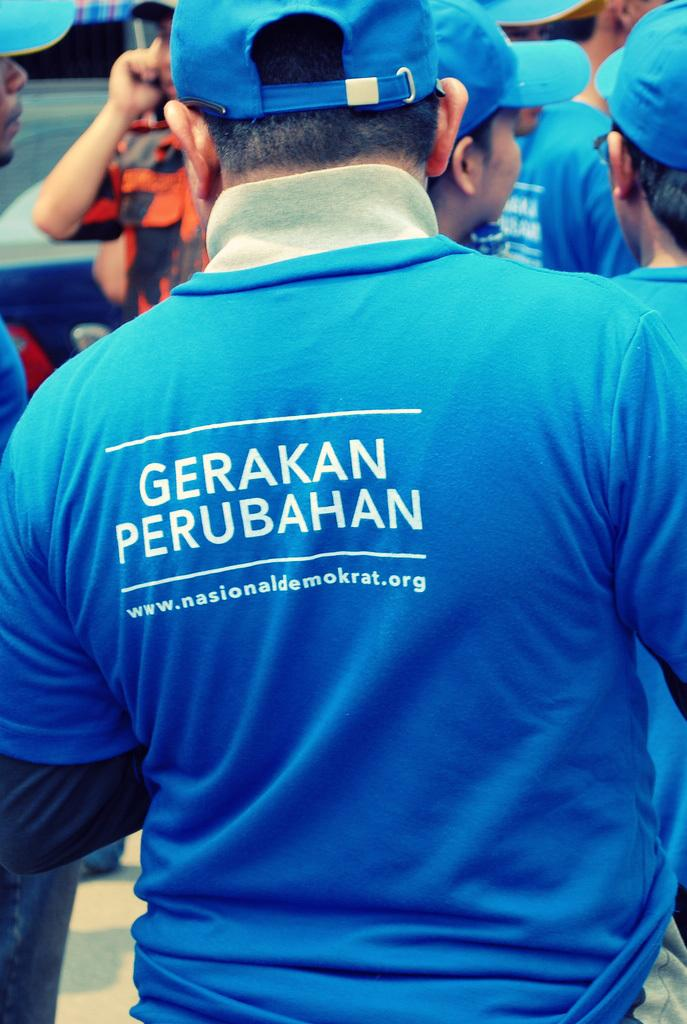What is the main subject of the image? The main subject of the image is a group of people. What are the people wearing on their heads? The people are wearing blue color caps. What else are the people wearing that is the same color as their caps? The people are also wearing blue color t-shirts. What type of pin can be seen on the people's t-shirts in the image? There is no pin visible on the people's t-shirts in the image. What kind of chain is connecting the people in the image? There is no chain connecting the people in the image. 